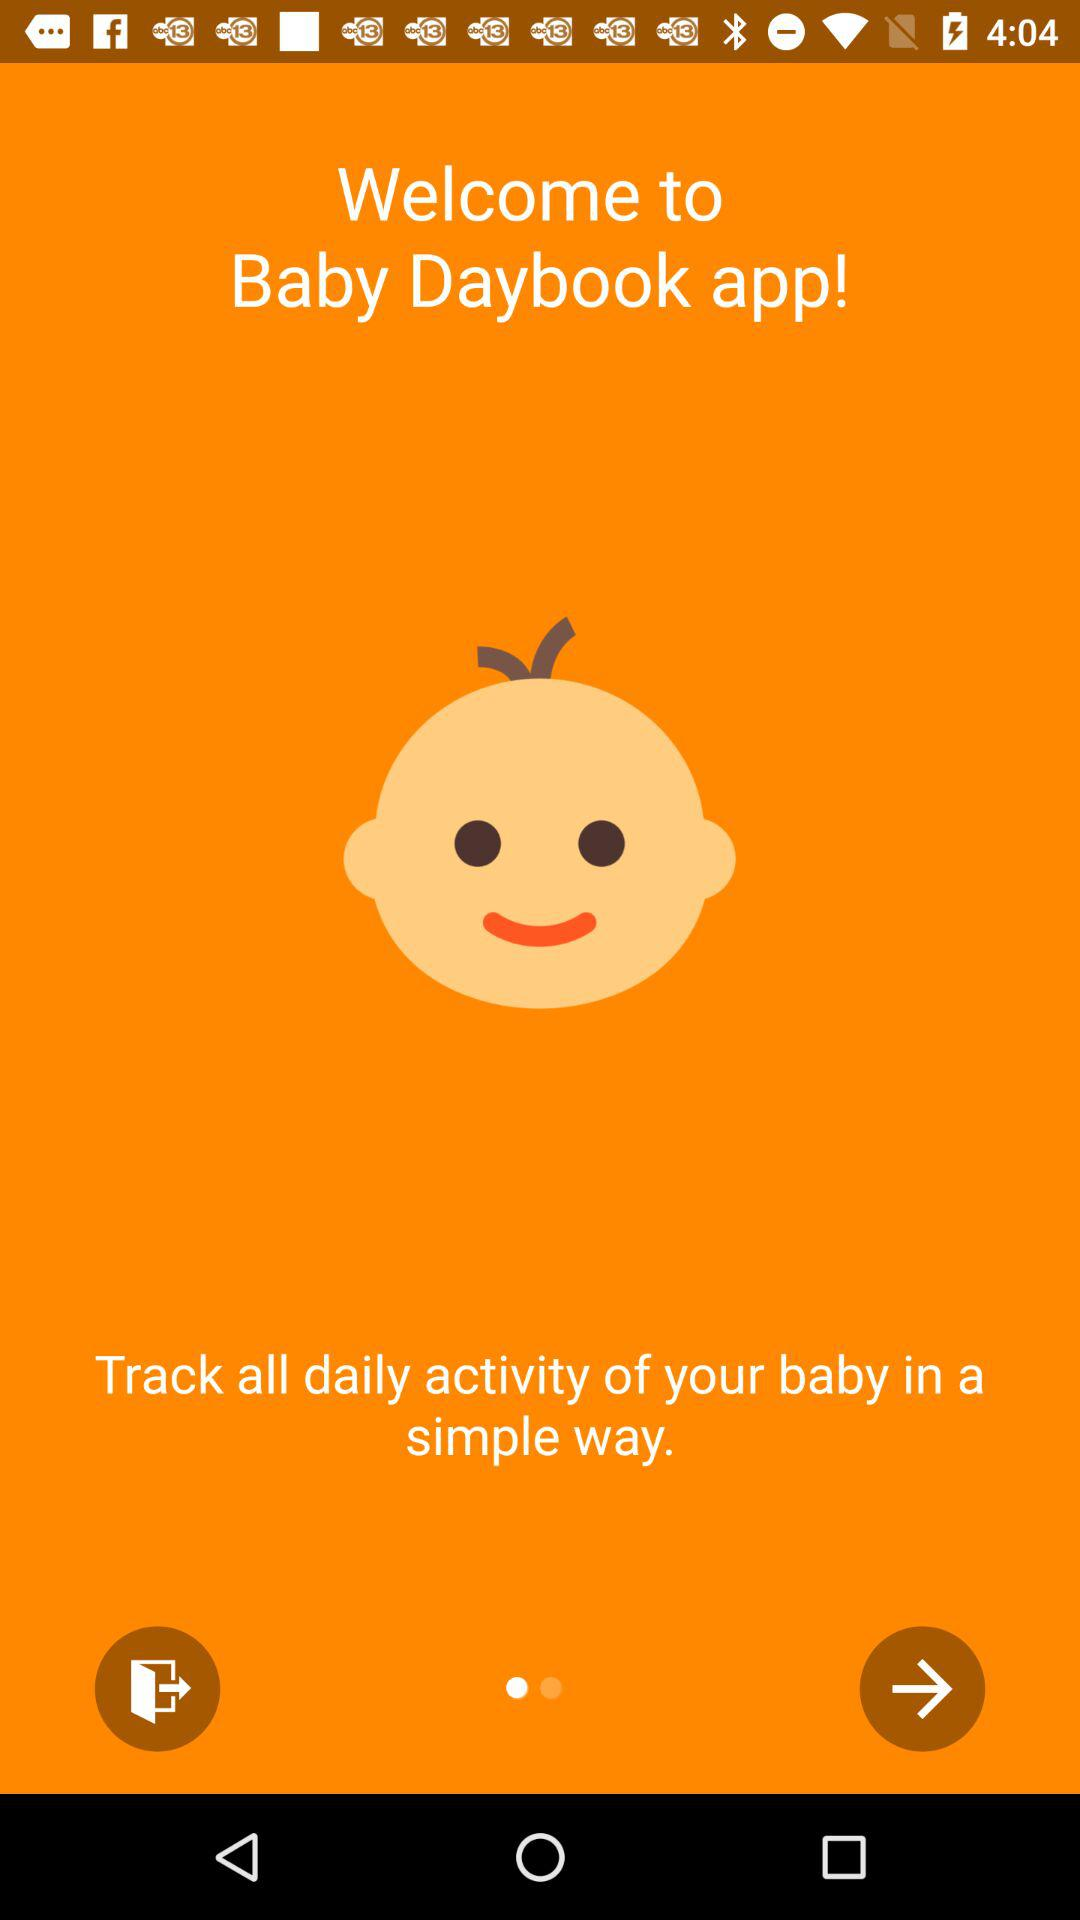What is the app name? The app name is "Baby Daybook". 